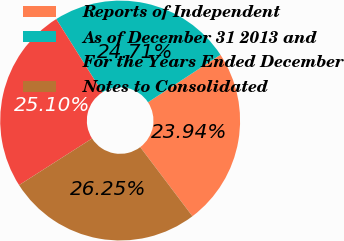Convert chart to OTSL. <chart><loc_0><loc_0><loc_500><loc_500><pie_chart><fcel>Reports of Independent<fcel>As of December 31 2013 and<fcel>For the Years Ended December<fcel>Notes to Consolidated<nl><fcel>23.94%<fcel>24.71%<fcel>25.1%<fcel>26.25%<nl></chart> 